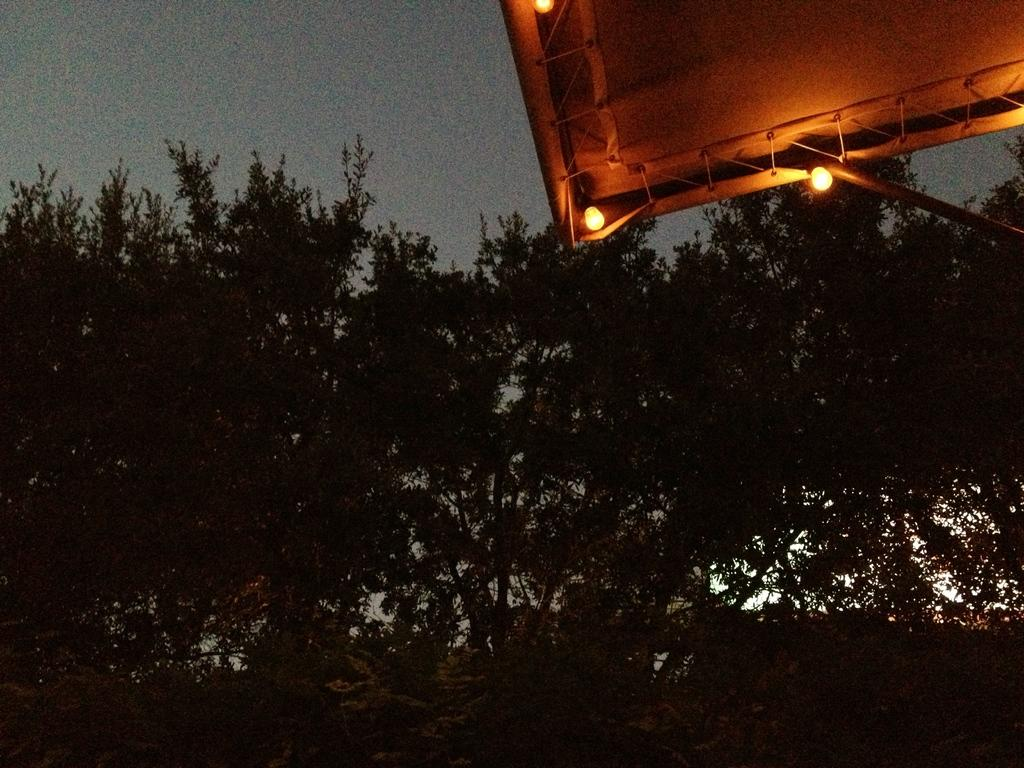What type of vegetation can be seen in the image? There are trees in the image. What objects are attached to the trees? There are blowing bulbs attached to the trees. Are the blowing bulbs connected to any other structure? Yes, the blowing bulbs are attached to a tent. What type of protest is taking place in the image? There is no protest present in the image; it features trees, blowing bulbs, and a tent. How many cushions can be seen on the ground in the image? There are no cushions present in the image. 